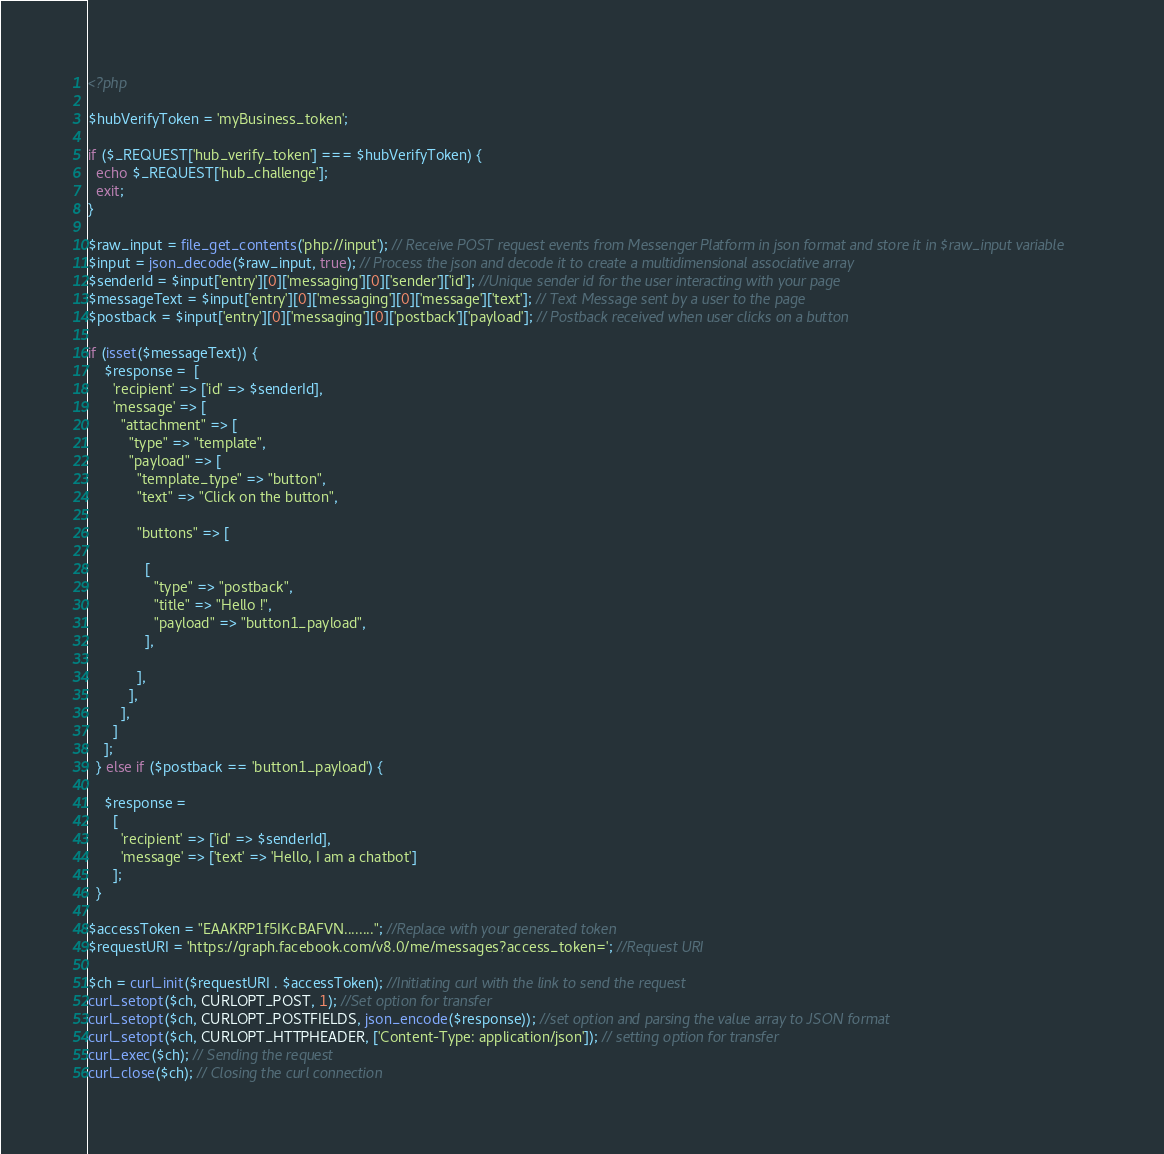Convert code to text. <code><loc_0><loc_0><loc_500><loc_500><_PHP_><?php

$hubVerifyToken = 'myBusiness_token';

if ($_REQUEST['hub_verify_token'] === $hubVerifyToken) {
  echo $_REQUEST['hub_challenge'];
  exit;
}

$raw_input = file_get_contents('php://input'); // Receive POST request events from Messenger Platform in json format and store it in $raw_input variable
$input = json_decode($raw_input, true); // Process the json and decode it to create a multidimensional associative array
$senderId = $input['entry'][0]['messaging'][0]['sender']['id']; //Unique sender id for the user interacting with your page
$messageText = $input['entry'][0]['messaging'][0]['message']['text']; // Text Message sent by a user to the page
$postback = $input['entry'][0]['messaging'][0]['postback']['payload']; // Postback received when user clicks on a button

if (isset($messageText)) {
    $response =  [
      'recipient' => ['id' => $senderId],
      'message' => [
        "attachment" => [
          "type" => "template",
          "payload" => [
            "template_type" => "button",
            "text" => "Click on the button",
  
            "buttons" => [
  
              [
                "type" => "postback",
                "title" => "Hello !",
                "payload" => "button1_payload",
              ],
  
            ],
          ],
        ],
      ]
    ];
  } else if ($postback == 'button1_payload') {
  
    $response =
      [
        'recipient' => ['id' => $senderId],
        'message' => ['text' => 'Hello, I am a chatbot']
      ];
  }

$accessToken = "EAAKRP1f5IKcBAFVN........"; //Replace with your generated token
$requestURI = 'https://graph.facebook.com/v8.0/me/messages?access_token='; //Request URI  

$ch = curl_init($requestURI . $accessToken); //Initiating curl with the link to send the request
curl_setopt($ch, CURLOPT_POST, 1); //Set option for transfer
curl_setopt($ch, CURLOPT_POSTFIELDS, json_encode($response)); //set option and parsing the value array to JSON format
curl_setopt($ch, CURLOPT_HTTPHEADER, ['Content-Type: application/json']); // setting option for transfer
curl_exec($ch); // Sending the request
curl_close($ch); // Closing the curl connection
</code> 